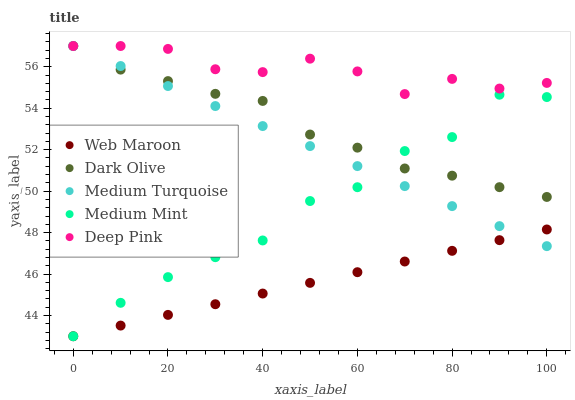Does Web Maroon have the minimum area under the curve?
Answer yes or no. Yes. Does Deep Pink have the maximum area under the curve?
Answer yes or no. Yes. Does Dark Olive have the minimum area under the curve?
Answer yes or no. No. Does Dark Olive have the maximum area under the curve?
Answer yes or no. No. Is Web Maroon the smoothest?
Answer yes or no. Yes. Is Medium Mint the roughest?
Answer yes or no. Yes. Is Dark Olive the smoothest?
Answer yes or no. No. Is Dark Olive the roughest?
Answer yes or no. No. Does Medium Mint have the lowest value?
Answer yes or no. Yes. Does Dark Olive have the lowest value?
Answer yes or no. No. Does Deep Pink have the highest value?
Answer yes or no. Yes. Does Web Maroon have the highest value?
Answer yes or no. No. Is Medium Mint less than Deep Pink?
Answer yes or no. Yes. Is Dark Olive greater than Web Maroon?
Answer yes or no. Yes. Does Medium Mint intersect Medium Turquoise?
Answer yes or no. Yes. Is Medium Mint less than Medium Turquoise?
Answer yes or no. No. Is Medium Mint greater than Medium Turquoise?
Answer yes or no. No. Does Medium Mint intersect Deep Pink?
Answer yes or no. No. 